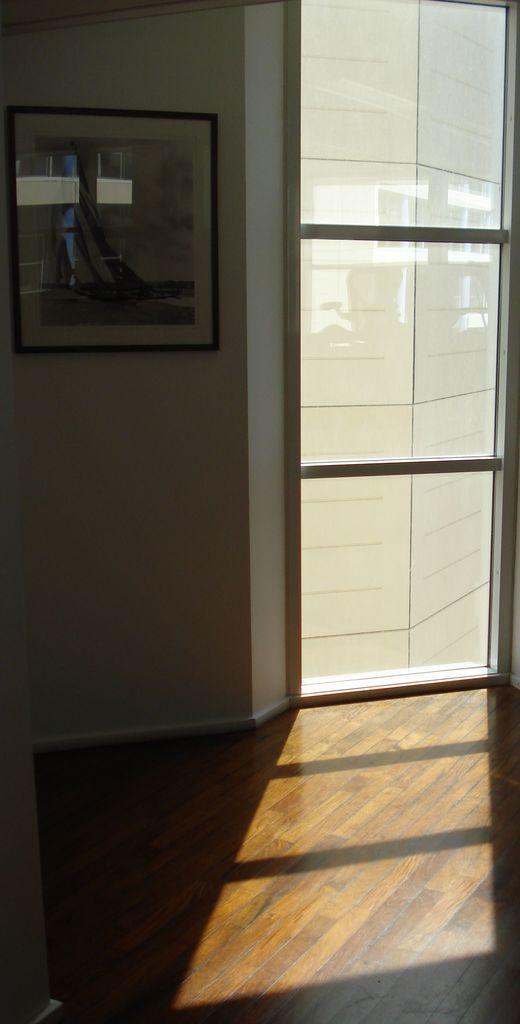In one or two sentences, can you explain what this image depicts? In this picture we can see photo frame near to the door. Through the door we can see building. On the bottom there is a wooden floor. 